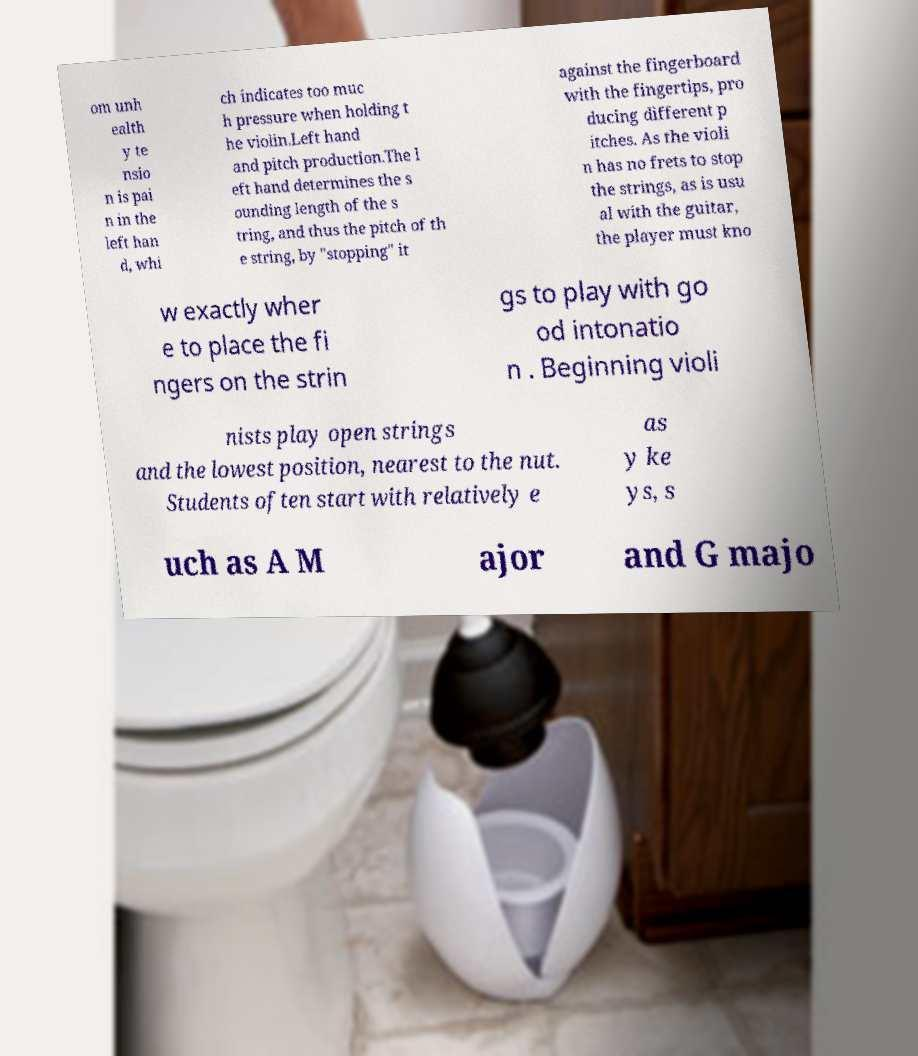Can you accurately transcribe the text from the provided image for me? om unh ealth y te nsio n is pai n in the left han d, whi ch indicates too muc h pressure when holding t he violin.Left hand and pitch production.The l eft hand determines the s ounding length of the s tring, and thus the pitch of th e string, by "stopping" it against the fingerboard with the fingertips, pro ducing different p itches. As the violi n has no frets to stop the strings, as is usu al with the guitar, the player must kno w exactly wher e to place the fi ngers on the strin gs to play with go od intonatio n . Beginning violi nists play open strings and the lowest position, nearest to the nut. Students often start with relatively e as y ke ys, s uch as A M ajor and G majo 